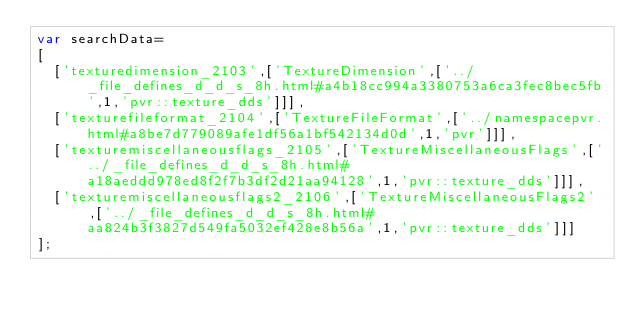<code> <loc_0><loc_0><loc_500><loc_500><_JavaScript_>var searchData=
[
  ['texturedimension_2103',['TextureDimension',['../_file_defines_d_d_s_8h.html#a4b18cc994a3380753a6ca3fec8bec5fb',1,'pvr::texture_dds']]],
  ['texturefileformat_2104',['TextureFileFormat',['../namespacepvr.html#a8be7d779089afe1df56a1bf542134d0d',1,'pvr']]],
  ['texturemiscellaneousflags_2105',['TextureMiscellaneousFlags',['../_file_defines_d_d_s_8h.html#a18aeddd978ed8f2f7b3df2d21aa94128',1,'pvr::texture_dds']]],
  ['texturemiscellaneousflags2_2106',['TextureMiscellaneousFlags2',['../_file_defines_d_d_s_8h.html#aa824b3f3827d549fa5032ef428e8b56a',1,'pvr::texture_dds']]]
];
</code> 